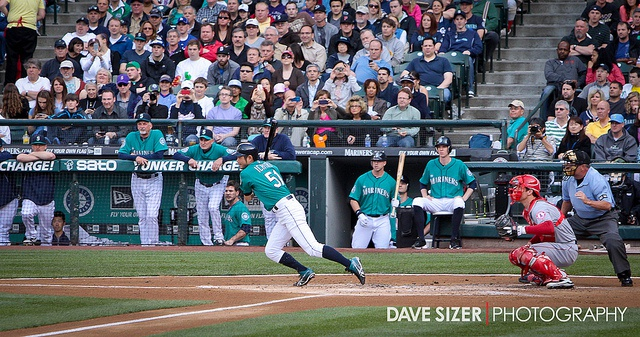Describe the objects in this image and their specific colors. I can see people in gray, black, teal, and lavender tones, people in gray, lavender, black, and teal tones, people in gray, brown, maroon, darkgray, and lavender tones, people in gray, darkgray, teal, lavender, and black tones, and people in gray, darkgray, black, lavender, and navy tones in this image. 